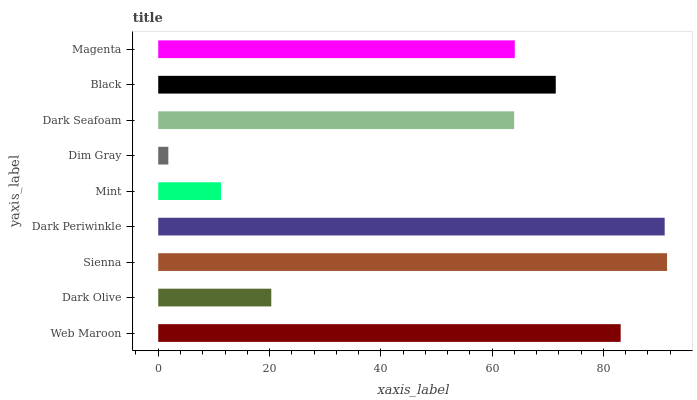Is Dim Gray the minimum?
Answer yes or no. Yes. Is Sienna the maximum?
Answer yes or no. Yes. Is Dark Olive the minimum?
Answer yes or no. No. Is Dark Olive the maximum?
Answer yes or no. No. Is Web Maroon greater than Dark Olive?
Answer yes or no. Yes. Is Dark Olive less than Web Maroon?
Answer yes or no. Yes. Is Dark Olive greater than Web Maroon?
Answer yes or no. No. Is Web Maroon less than Dark Olive?
Answer yes or no. No. Is Magenta the high median?
Answer yes or no. Yes. Is Magenta the low median?
Answer yes or no. Yes. Is Mint the high median?
Answer yes or no. No. Is Dark Periwinkle the low median?
Answer yes or no. No. 